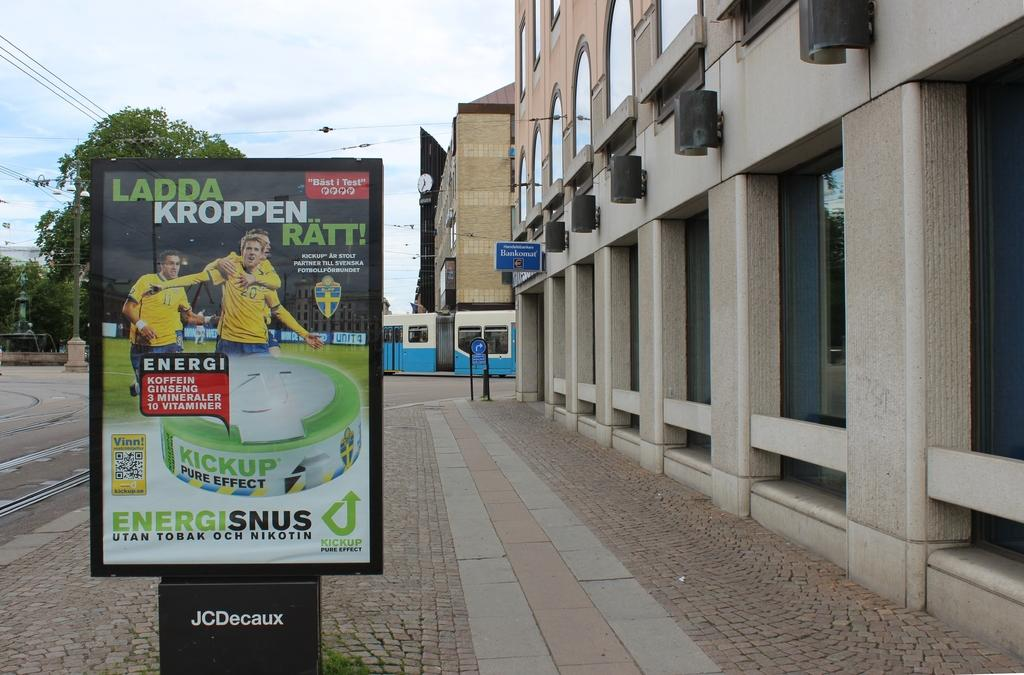<image>
Share a concise interpretation of the image provided. the sign for Ladda Kroppen Ratt has two men in yellow jerseys on it. 